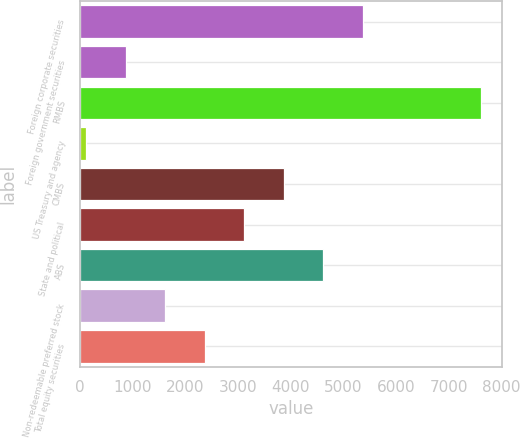Convert chart to OTSL. <chart><loc_0><loc_0><loc_500><loc_500><bar_chart><fcel>Foreign corporate securities<fcel>Foreign government securities<fcel>RMBS<fcel>US Treasury and agency<fcel>CMBS<fcel>State and political<fcel>ABS<fcel>Non-redeemable preferred stock<fcel>Total equity securities<nl><fcel>5372.2<fcel>868.6<fcel>7624<fcel>118<fcel>3871<fcel>3120.4<fcel>4621.6<fcel>1619.2<fcel>2369.8<nl></chart> 